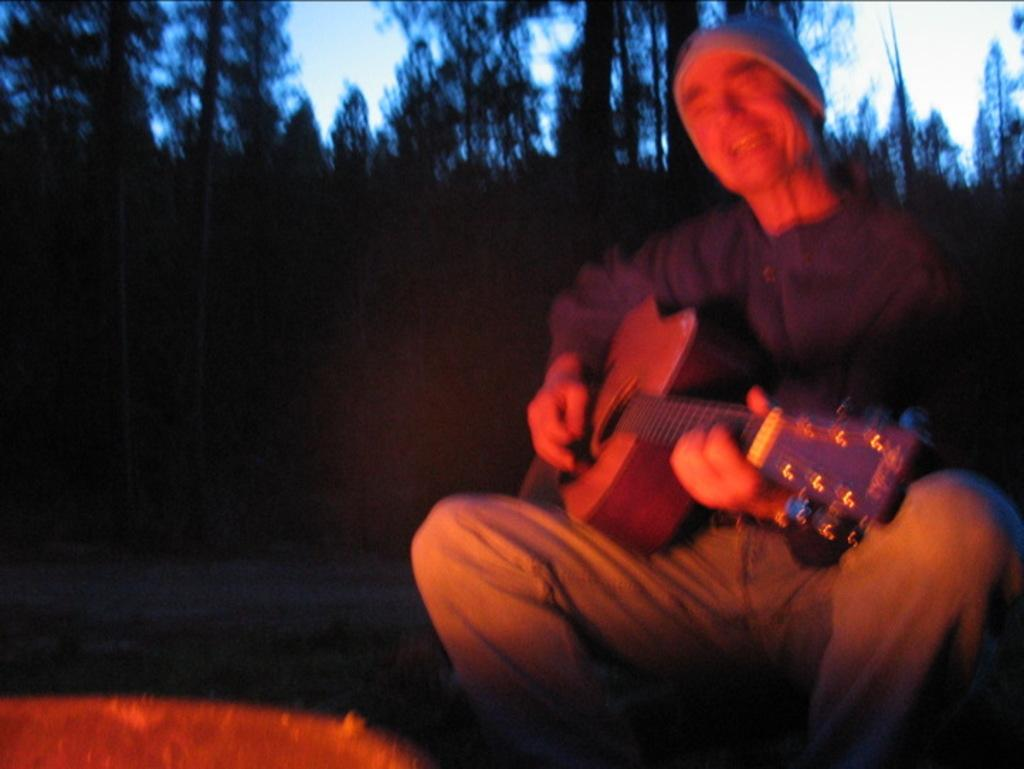What is the main subject of the image? There is a person in the image. Where is the person located in the image? The person is on the right side. What is the person doing in the image? The person is playing the guitar and singing a song. What can be seen in the background of the image? There are trees in the background of the image. What type of hand can be seen reaching out from the wall in the image? There is no hand or wall present in the image. 